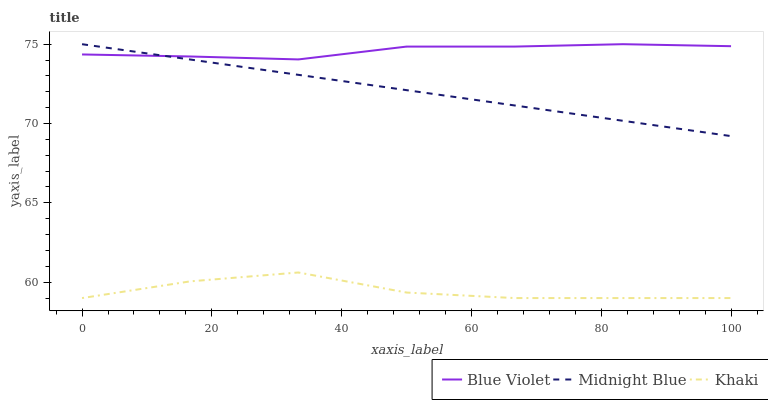Does Khaki have the minimum area under the curve?
Answer yes or no. Yes. Does Blue Violet have the maximum area under the curve?
Answer yes or no. Yes. Does Midnight Blue have the minimum area under the curve?
Answer yes or no. No. Does Midnight Blue have the maximum area under the curve?
Answer yes or no. No. Is Midnight Blue the smoothest?
Answer yes or no. Yes. Is Khaki the roughest?
Answer yes or no. Yes. Is Blue Violet the smoothest?
Answer yes or no. No. Is Blue Violet the roughest?
Answer yes or no. No. Does Midnight Blue have the lowest value?
Answer yes or no. No. Is Khaki less than Midnight Blue?
Answer yes or no. Yes. Is Blue Violet greater than Khaki?
Answer yes or no. Yes. Does Khaki intersect Midnight Blue?
Answer yes or no. No. 